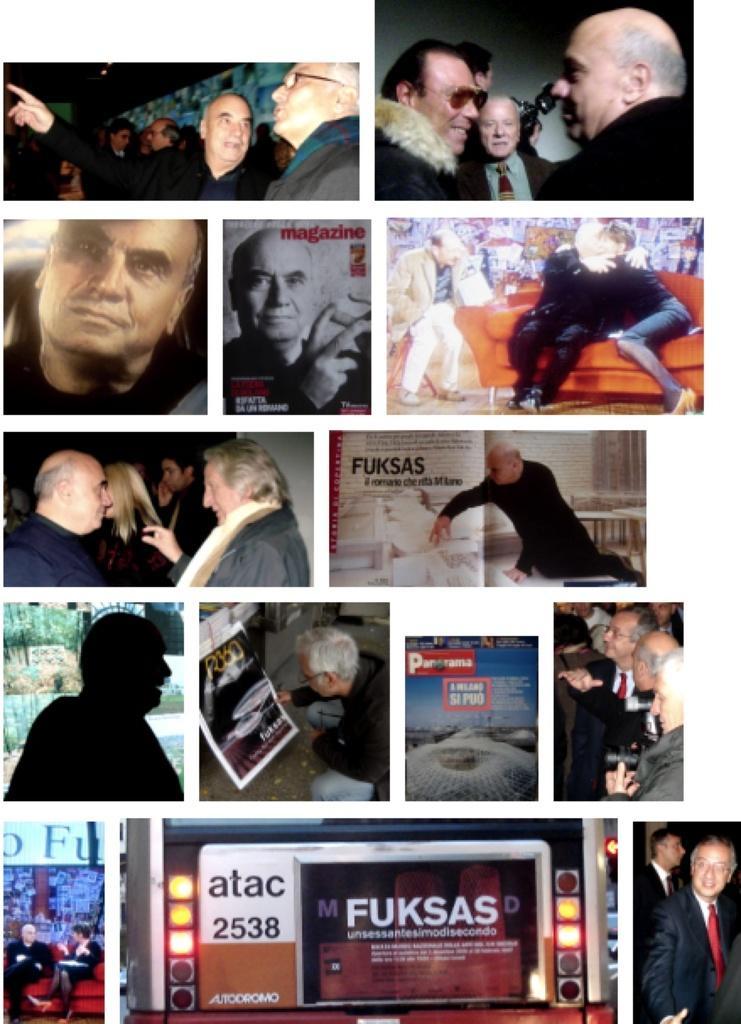How would you summarize this image in a sentence or two? This is a collage. In the picture there are lot of men, posters. At the bottom there is a vehicle. On the left there are people sitting in couch. At the top towards right there are people sitting in couch. 